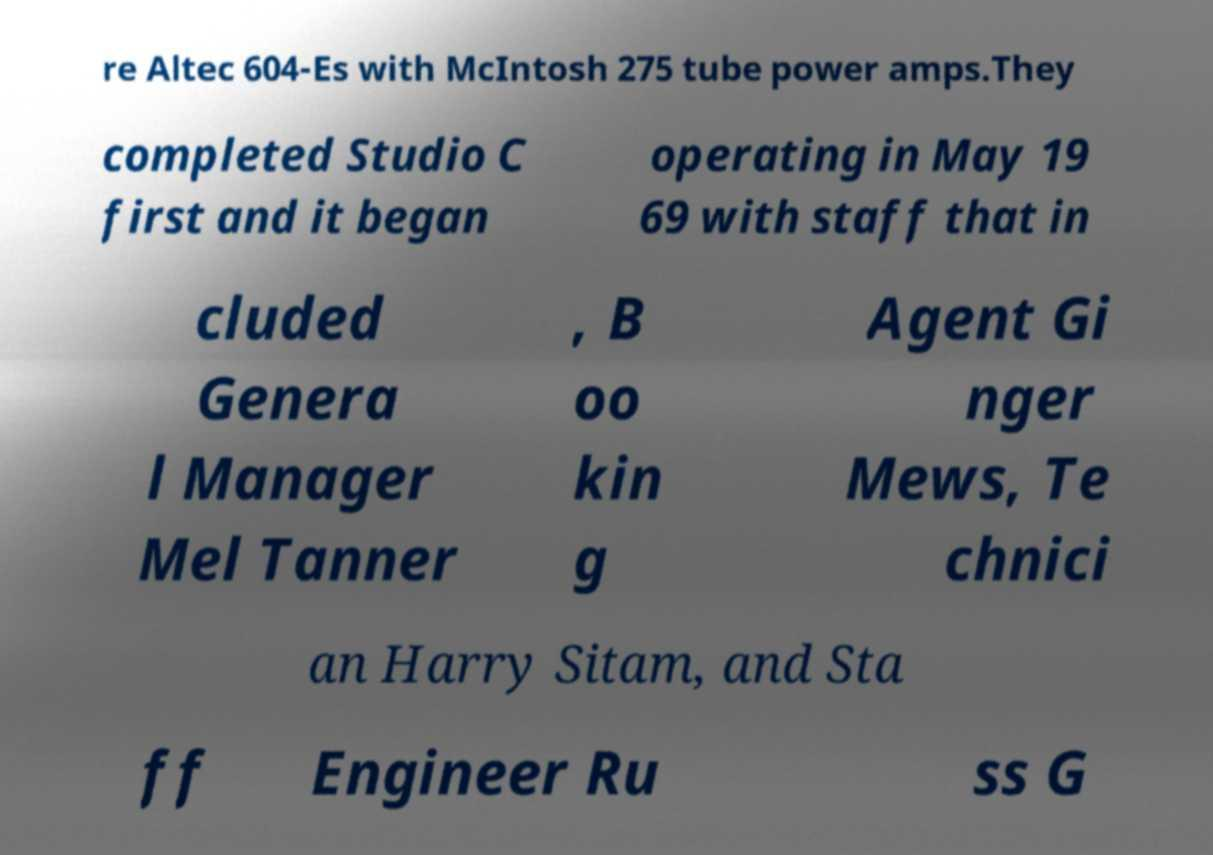For documentation purposes, I need the text within this image transcribed. Could you provide that? re Altec 604-Es with McIntosh 275 tube power amps.They completed Studio C first and it began operating in May 19 69 with staff that in cluded Genera l Manager Mel Tanner , B oo kin g Agent Gi nger Mews, Te chnici an Harry Sitam, and Sta ff Engineer Ru ss G 